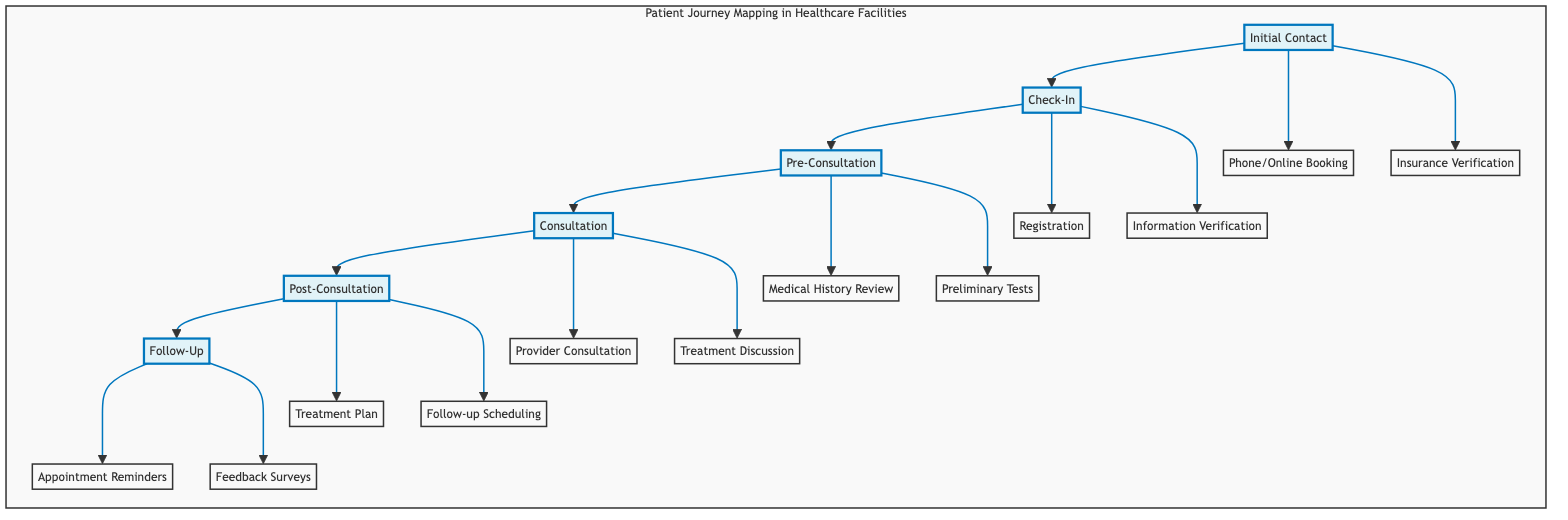What's the first step in the patient journey? The first step labeled in the diagram is "Initial Contact." This is directly indicated as the starting point of the flowchart.
Answer: Initial Contact How many steps are there in the patient journey? By counting the steps shown in the diagram, there are six distinct steps from "Initial Contact" to "Follow-Up."
Answer: six What actions happen during the "Check-In" step? In the "Check-In" step, the actions are: "Patient arrives at the facility," "Completes registration forms," and "Verification of personal and insurance information." These actions are listed directly beneath the "Check-In" node.
Answer: Patient arrives at the facility, Completes registration forms, Verification of personal and insurance information What are the touchpoints for the "Pre-Consultation" step? The touchpoints for the "Pre-Consultation" step are "Examination room" and "Diagnostic lab." These touchpoints are specified under the "Pre-Consultation" node in the diagram.
Answer: Examination room, Diagnostic lab Which steps contain actions related to scheduling? "Post-Consultation" and "Follow-Up" are the steps that contain actions related to scheduling. In "Post-Consultation," it involves scheduling follow-up appointments, and in "Follow-Up," it includes appointment reminders.
Answer: Post-Consultation, Follow-Up What is the main focus of evidence-based design in the "Consultation" step? The evidence-based design considerations in the "Consultation" step focus on "Confidentiality and privacy in consultation rooms" and "Adequate space for patient and family members," which are explicitly stated underneath the "Consultation" node.
Answer: Confidentiality and privacy in consultation rooms, Adequate space for patient and family members How does the "Initial Contact" step connect to "Check-In"? The "Initial Contact" step connects to "Check-In" through a direct flow indicated by the arrow, showing that after the initial contact is made, the next step is check-in.
Answer: Through a direct arrow connection What type of design considerations are mentioned in relation to "Checkout area"? The design considerations related to the "Checkout area" focus on a "Fast and efficient checkout process" and "Accessible in-house pharmacy," which are aimed at improving patient interactions.
Answer: Fast and efficient checkout process, Accessible in-house pharmacy 